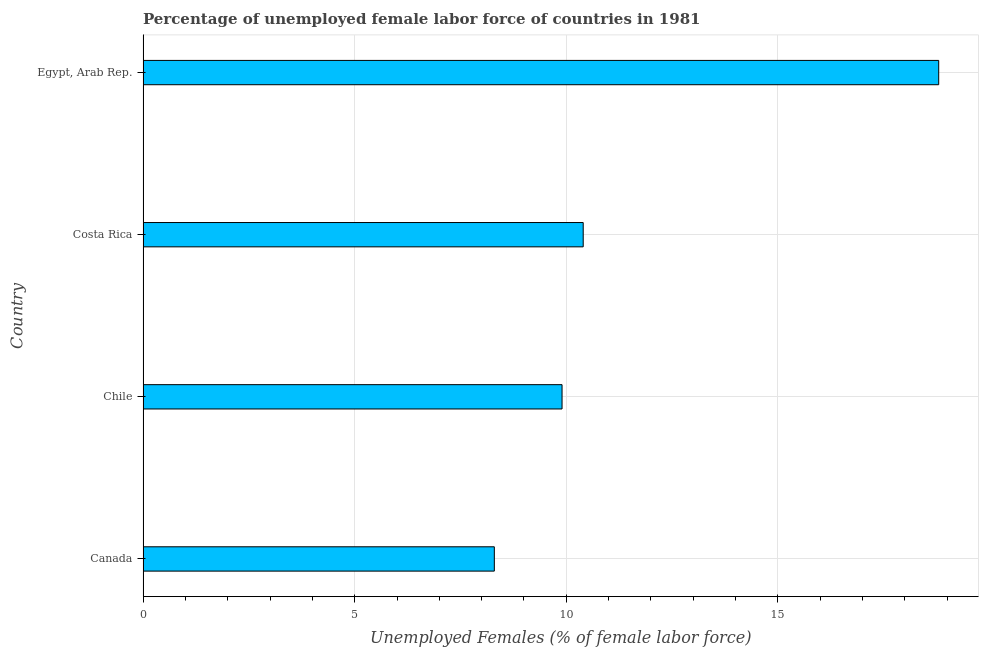What is the title of the graph?
Your answer should be very brief. Percentage of unemployed female labor force of countries in 1981. What is the label or title of the X-axis?
Your response must be concise. Unemployed Females (% of female labor force). What is the label or title of the Y-axis?
Keep it short and to the point. Country. What is the total unemployed female labour force in Chile?
Provide a short and direct response. 9.9. Across all countries, what is the maximum total unemployed female labour force?
Your response must be concise. 18.8. Across all countries, what is the minimum total unemployed female labour force?
Your answer should be compact. 8.3. In which country was the total unemployed female labour force maximum?
Give a very brief answer. Egypt, Arab Rep. In which country was the total unemployed female labour force minimum?
Your response must be concise. Canada. What is the sum of the total unemployed female labour force?
Offer a very short reply. 47.4. What is the average total unemployed female labour force per country?
Your response must be concise. 11.85. What is the median total unemployed female labour force?
Your response must be concise. 10.15. What is the ratio of the total unemployed female labour force in Canada to that in Costa Rica?
Your answer should be very brief. 0.8. Is the difference between the total unemployed female labour force in Canada and Chile greater than the difference between any two countries?
Your answer should be compact. No. What is the difference between the highest and the second highest total unemployed female labour force?
Your response must be concise. 8.4. In how many countries, is the total unemployed female labour force greater than the average total unemployed female labour force taken over all countries?
Your response must be concise. 1. How many bars are there?
Your answer should be very brief. 4. Are all the bars in the graph horizontal?
Offer a very short reply. Yes. How many countries are there in the graph?
Make the answer very short. 4. Are the values on the major ticks of X-axis written in scientific E-notation?
Provide a short and direct response. No. What is the Unemployed Females (% of female labor force) in Canada?
Ensure brevity in your answer.  8.3. What is the Unemployed Females (% of female labor force) of Chile?
Give a very brief answer. 9.9. What is the Unemployed Females (% of female labor force) in Costa Rica?
Make the answer very short. 10.4. What is the Unemployed Females (% of female labor force) of Egypt, Arab Rep.?
Make the answer very short. 18.8. What is the difference between the Unemployed Females (% of female labor force) in Canada and Costa Rica?
Make the answer very short. -2.1. What is the ratio of the Unemployed Females (% of female labor force) in Canada to that in Chile?
Offer a terse response. 0.84. What is the ratio of the Unemployed Females (% of female labor force) in Canada to that in Costa Rica?
Ensure brevity in your answer.  0.8. What is the ratio of the Unemployed Females (% of female labor force) in Canada to that in Egypt, Arab Rep.?
Offer a very short reply. 0.44. What is the ratio of the Unemployed Females (% of female labor force) in Chile to that in Egypt, Arab Rep.?
Your answer should be compact. 0.53. What is the ratio of the Unemployed Females (% of female labor force) in Costa Rica to that in Egypt, Arab Rep.?
Your answer should be compact. 0.55. 